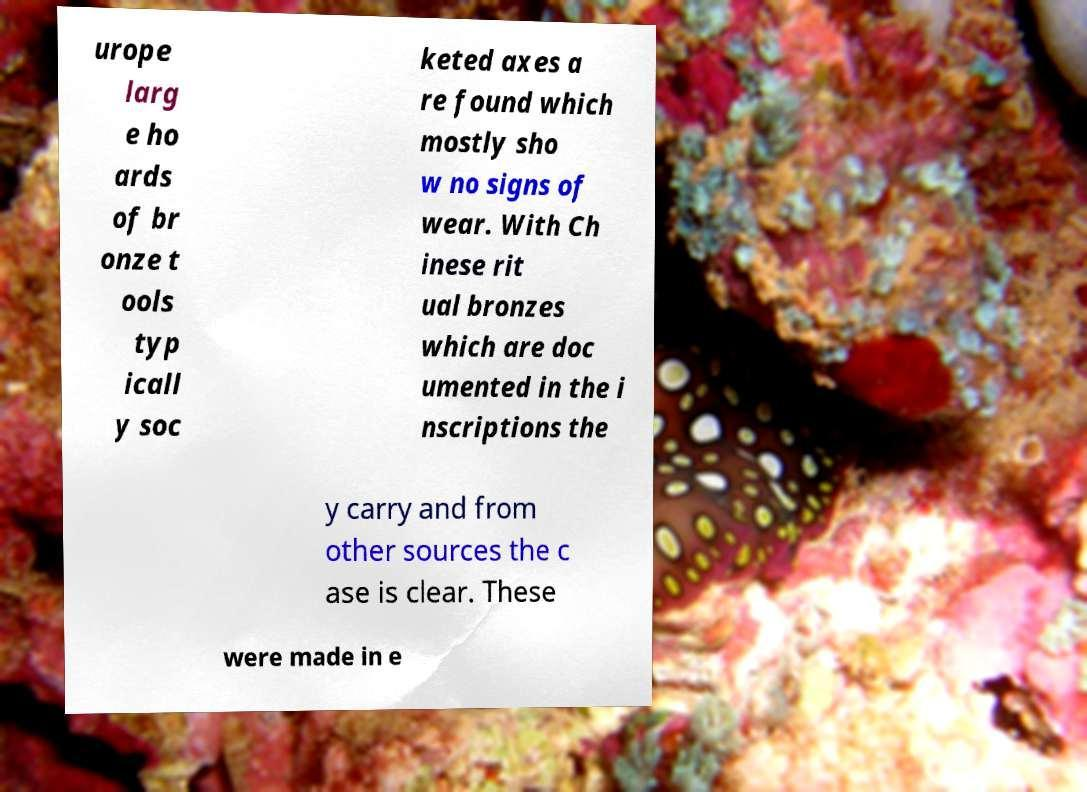Please identify and transcribe the text found in this image. urope larg e ho ards of br onze t ools typ icall y soc keted axes a re found which mostly sho w no signs of wear. With Ch inese rit ual bronzes which are doc umented in the i nscriptions the y carry and from other sources the c ase is clear. These were made in e 